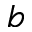<formula> <loc_0><loc_0><loc_500><loc_500>b</formula> 